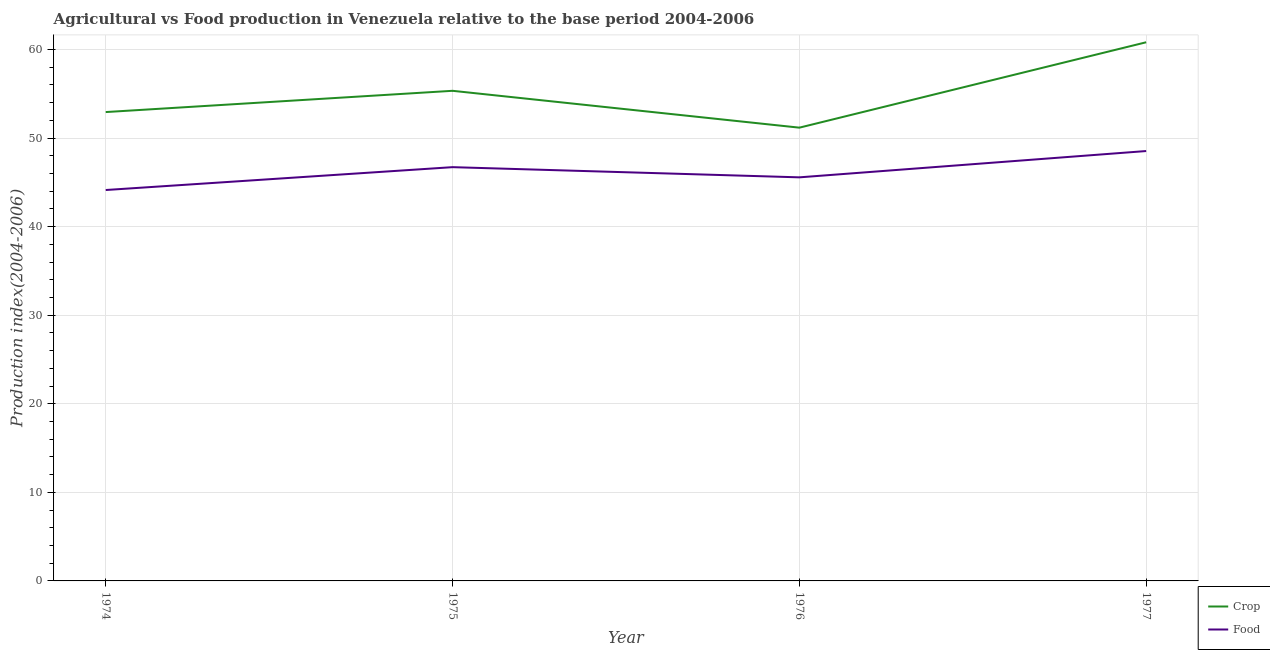How many different coloured lines are there?
Your response must be concise. 2. Does the line corresponding to food production index intersect with the line corresponding to crop production index?
Provide a short and direct response. No. Is the number of lines equal to the number of legend labels?
Your response must be concise. Yes. What is the crop production index in 1977?
Your response must be concise. 60.81. Across all years, what is the maximum food production index?
Your answer should be compact. 48.53. Across all years, what is the minimum crop production index?
Keep it short and to the point. 51.17. In which year was the food production index minimum?
Ensure brevity in your answer.  1974. What is the total food production index in the graph?
Provide a short and direct response. 184.93. What is the difference between the food production index in 1974 and that in 1976?
Ensure brevity in your answer.  -1.43. What is the difference between the food production index in 1974 and the crop production index in 1977?
Keep it short and to the point. -16.68. What is the average food production index per year?
Provide a succinct answer. 46.23. In the year 1977, what is the difference between the crop production index and food production index?
Your answer should be compact. 12.28. What is the ratio of the crop production index in 1974 to that in 1977?
Make the answer very short. 0.87. What is the difference between the highest and the second highest crop production index?
Your answer should be compact. 5.48. What is the difference between the highest and the lowest food production index?
Provide a succinct answer. 4.4. In how many years, is the food production index greater than the average food production index taken over all years?
Offer a terse response. 2. Is the crop production index strictly greater than the food production index over the years?
Keep it short and to the point. Yes. Is the crop production index strictly less than the food production index over the years?
Give a very brief answer. No. How many lines are there?
Provide a succinct answer. 2. How many years are there in the graph?
Offer a very short reply. 4. Does the graph contain grids?
Provide a short and direct response. Yes. How many legend labels are there?
Ensure brevity in your answer.  2. What is the title of the graph?
Give a very brief answer. Agricultural vs Food production in Venezuela relative to the base period 2004-2006. What is the label or title of the Y-axis?
Offer a very short reply. Production index(2004-2006). What is the Production index(2004-2006) in Crop in 1974?
Ensure brevity in your answer.  52.93. What is the Production index(2004-2006) of Food in 1974?
Keep it short and to the point. 44.13. What is the Production index(2004-2006) of Crop in 1975?
Ensure brevity in your answer.  55.33. What is the Production index(2004-2006) in Food in 1975?
Your answer should be very brief. 46.71. What is the Production index(2004-2006) in Crop in 1976?
Ensure brevity in your answer.  51.17. What is the Production index(2004-2006) in Food in 1976?
Make the answer very short. 45.56. What is the Production index(2004-2006) in Crop in 1977?
Your answer should be very brief. 60.81. What is the Production index(2004-2006) in Food in 1977?
Your answer should be compact. 48.53. Across all years, what is the maximum Production index(2004-2006) in Crop?
Offer a terse response. 60.81. Across all years, what is the maximum Production index(2004-2006) of Food?
Your answer should be very brief. 48.53. Across all years, what is the minimum Production index(2004-2006) of Crop?
Your response must be concise. 51.17. Across all years, what is the minimum Production index(2004-2006) of Food?
Offer a very short reply. 44.13. What is the total Production index(2004-2006) of Crop in the graph?
Make the answer very short. 220.24. What is the total Production index(2004-2006) of Food in the graph?
Your answer should be compact. 184.93. What is the difference between the Production index(2004-2006) of Food in 1974 and that in 1975?
Offer a very short reply. -2.58. What is the difference between the Production index(2004-2006) of Crop in 1974 and that in 1976?
Your answer should be very brief. 1.76. What is the difference between the Production index(2004-2006) in Food in 1974 and that in 1976?
Ensure brevity in your answer.  -1.43. What is the difference between the Production index(2004-2006) in Crop in 1974 and that in 1977?
Offer a terse response. -7.88. What is the difference between the Production index(2004-2006) in Food in 1974 and that in 1977?
Provide a short and direct response. -4.4. What is the difference between the Production index(2004-2006) of Crop in 1975 and that in 1976?
Your answer should be compact. 4.16. What is the difference between the Production index(2004-2006) of Food in 1975 and that in 1976?
Offer a very short reply. 1.15. What is the difference between the Production index(2004-2006) of Crop in 1975 and that in 1977?
Provide a short and direct response. -5.48. What is the difference between the Production index(2004-2006) in Food in 1975 and that in 1977?
Make the answer very short. -1.82. What is the difference between the Production index(2004-2006) of Crop in 1976 and that in 1977?
Keep it short and to the point. -9.64. What is the difference between the Production index(2004-2006) in Food in 1976 and that in 1977?
Make the answer very short. -2.97. What is the difference between the Production index(2004-2006) in Crop in 1974 and the Production index(2004-2006) in Food in 1975?
Ensure brevity in your answer.  6.22. What is the difference between the Production index(2004-2006) in Crop in 1974 and the Production index(2004-2006) in Food in 1976?
Your response must be concise. 7.37. What is the difference between the Production index(2004-2006) of Crop in 1974 and the Production index(2004-2006) of Food in 1977?
Your answer should be very brief. 4.4. What is the difference between the Production index(2004-2006) of Crop in 1975 and the Production index(2004-2006) of Food in 1976?
Your answer should be very brief. 9.77. What is the difference between the Production index(2004-2006) in Crop in 1976 and the Production index(2004-2006) in Food in 1977?
Ensure brevity in your answer.  2.64. What is the average Production index(2004-2006) in Crop per year?
Provide a succinct answer. 55.06. What is the average Production index(2004-2006) in Food per year?
Your answer should be very brief. 46.23. In the year 1975, what is the difference between the Production index(2004-2006) of Crop and Production index(2004-2006) of Food?
Your response must be concise. 8.62. In the year 1976, what is the difference between the Production index(2004-2006) of Crop and Production index(2004-2006) of Food?
Offer a terse response. 5.61. In the year 1977, what is the difference between the Production index(2004-2006) of Crop and Production index(2004-2006) of Food?
Your response must be concise. 12.28. What is the ratio of the Production index(2004-2006) in Crop in 1974 to that in 1975?
Your answer should be very brief. 0.96. What is the ratio of the Production index(2004-2006) in Food in 1974 to that in 1975?
Provide a succinct answer. 0.94. What is the ratio of the Production index(2004-2006) of Crop in 1974 to that in 1976?
Provide a short and direct response. 1.03. What is the ratio of the Production index(2004-2006) of Food in 1974 to that in 1976?
Your answer should be compact. 0.97. What is the ratio of the Production index(2004-2006) of Crop in 1974 to that in 1977?
Keep it short and to the point. 0.87. What is the ratio of the Production index(2004-2006) in Food in 1974 to that in 1977?
Keep it short and to the point. 0.91. What is the ratio of the Production index(2004-2006) in Crop in 1975 to that in 1976?
Make the answer very short. 1.08. What is the ratio of the Production index(2004-2006) in Food in 1975 to that in 1976?
Your response must be concise. 1.03. What is the ratio of the Production index(2004-2006) in Crop in 1975 to that in 1977?
Make the answer very short. 0.91. What is the ratio of the Production index(2004-2006) in Food in 1975 to that in 1977?
Provide a short and direct response. 0.96. What is the ratio of the Production index(2004-2006) of Crop in 1976 to that in 1977?
Give a very brief answer. 0.84. What is the ratio of the Production index(2004-2006) of Food in 1976 to that in 1977?
Give a very brief answer. 0.94. What is the difference between the highest and the second highest Production index(2004-2006) of Crop?
Your answer should be compact. 5.48. What is the difference between the highest and the second highest Production index(2004-2006) of Food?
Provide a succinct answer. 1.82. What is the difference between the highest and the lowest Production index(2004-2006) in Crop?
Give a very brief answer. 9.64. 